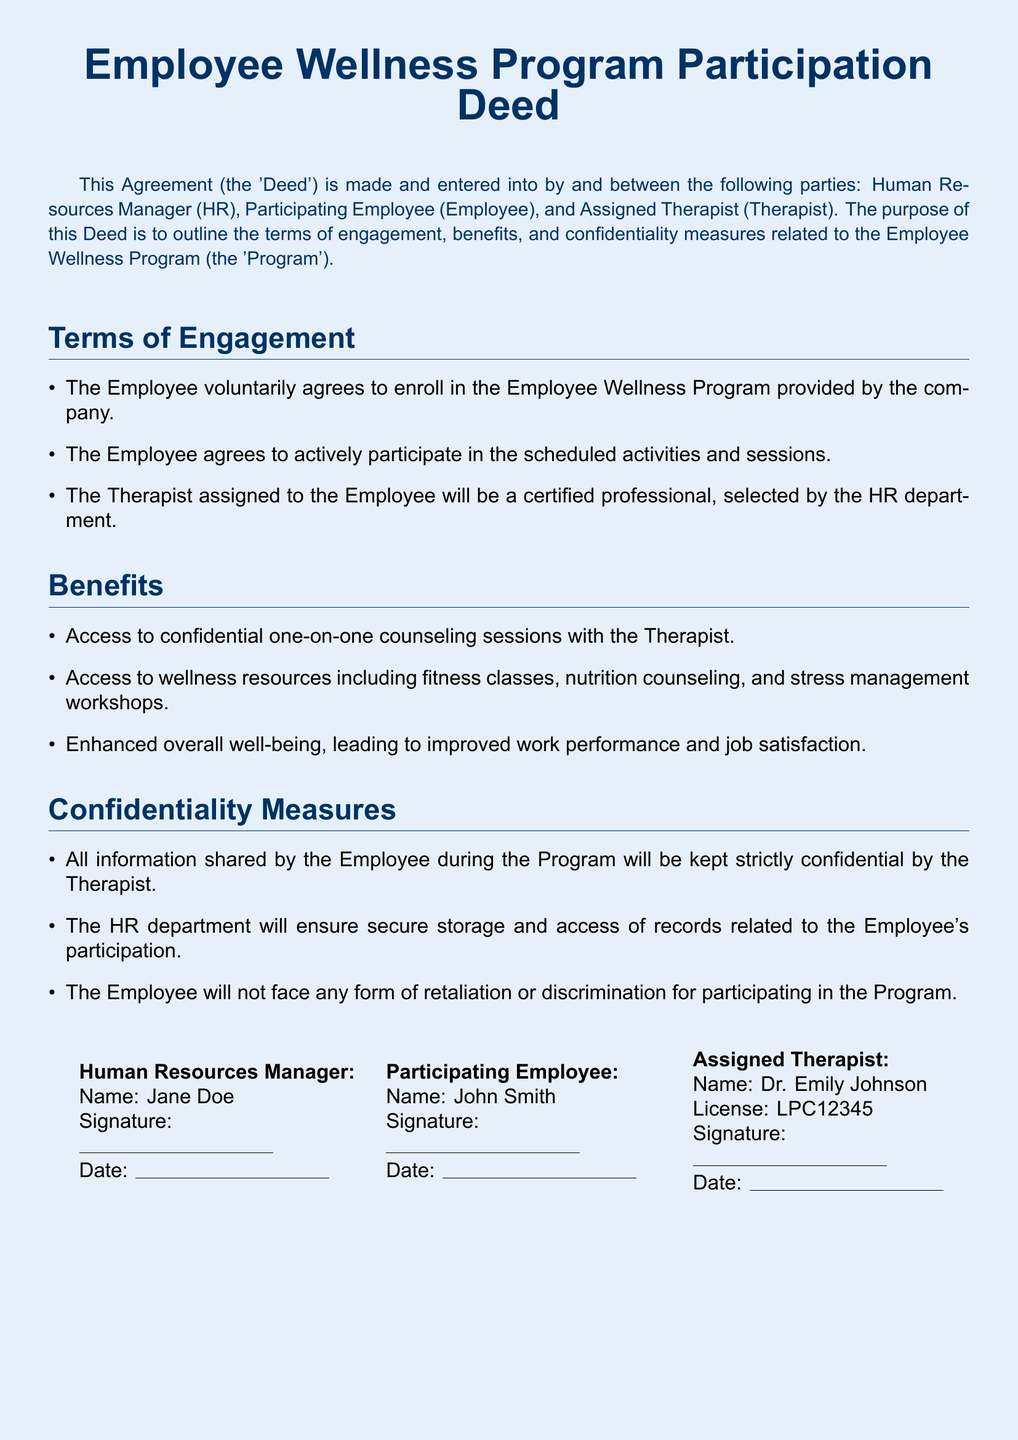What is the title of the document? The title is explicitly stated at the top of the document.
Answer: Employee Wellness Program Participation Deed Who is the Human Resources Manager? The document provides the name of the HR manager in the signature section.
Answer: Jane Doe What is the name of the participating employee? The name of the employee is given in the signature section of the document.
Answer: John Smith What is the license number of the assigned therapist? The license number is specified next to the therapist's name in the signature section.
Answer: LPC12345 What type of sessions will the employee have access to? The document mentions the type of sessions clearly in the benefits section.
Answer: One-on-one counseling sessions What benefit is highlighted related to job performance? The document outlines a specific benefit in the benefits section.
Answer: Improved work performance What measure is in place to protect employee confidentiality? The section on confidentiality measures specifies this assurance.
Answer: Strictly confidential What does the employee agree to in terms of participation? The terms of engagement describe the agreement made by the employee.
Answer: Actively participate in the scheduled activities Who selects the assigned therapist? The document specifies which party is responsible for the selection of the therapist.
Answer: HR department 